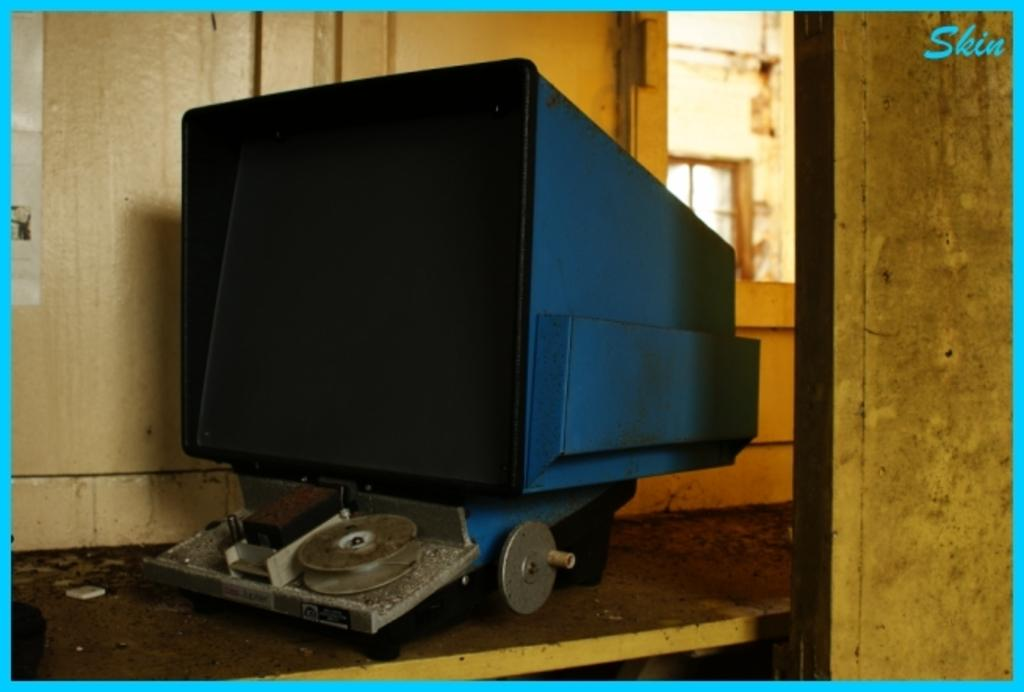What is the main object on the wooden surface in the image? There is a machine on a wooden surface in the image. What can be seen in the background of the image? There is a wall and a window in the background of the image. Can you describe the possible architectural feature on the right side of the image? There may be a door on the right side of the image. What type of linen is draped over the machine in the image? There is no linen draped over the machine in the image. Can you see any fish swimming in the background of the image? There are no fish visible in the image; it features a machine on a wooden surface with a wall and window in the background. 